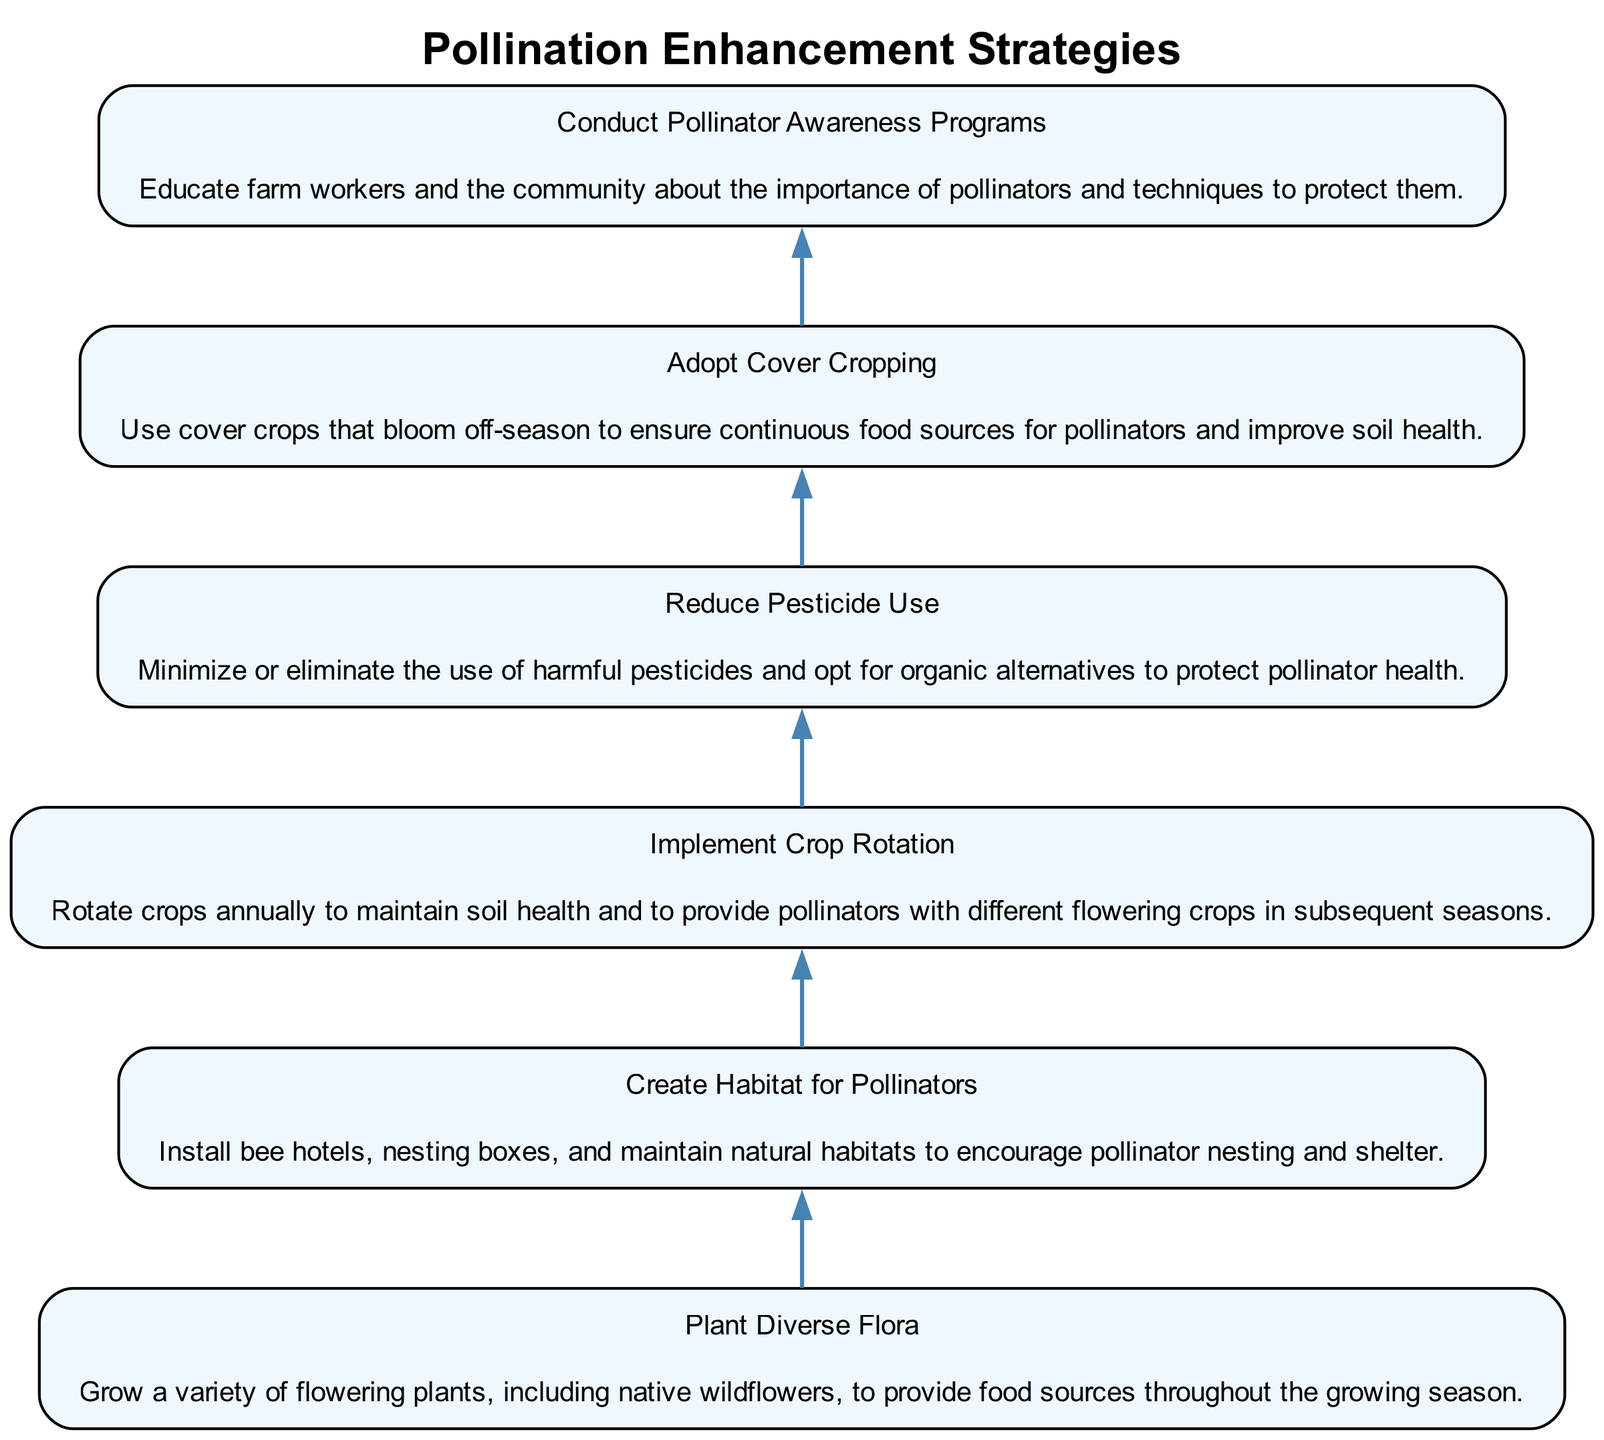What is the first strategy listed in the diagram? The diagram presents strategies in a bottom-up flow, with the first strategy being at the top. According to the data, the first strategy listed is "Plant Diverse Flora."
Answer: Plant Diverse Flora How many strategies are outlined in the diagram? The diagram contains six nodes, each representing a strategy for pollination enhancement as outlined in the data provided.
Answer: 6 What is the purpose of "Create Habitat for Pollinators"? Each node in the diagram describes specific strategies, and "Create Habitat for Pollinators" focuses on installing bee hotels and maintaining habitats for nesting. This information is directly related to the description provided for that node.
Answer: Install bee hotels and nesting boxes Which strategy directly emphasizes reducing chemicals near pollinators? Among the strategies, "Reduce Pesticide Use" is specifically focused on minimizing harmful pesticides to protect pollinators. This information is contained within the explanation of the strategy in the diagram.
Answer: Reduce Pesticide Use Which two strategies focus on the education and awareness of pollinators? The two strategies that emphasize education and awareness are "Conduct Pollinator Awareness Programs" and "Create Habitat for Pollinators." "Conduct Pollinator Awareness Programs" explicitly mentions educating the community about pollinator importance, while "Create Habitat for Pollinators" implies a broader educational context regarding habitat.
Answer: Conduct Pollinator Awareness Programs, Create Habitat for Pollinators What does the flow direction from "Plant Diverse Flora" to "Implement Crop Rotation" suggest? The flow from "Plant Diverse Flora" to "Implement Crop Rotation" indicates a sequential relationship where the diversity in flora allows for rotating crops, which is beneficial for soil and pollinators alike. This suggests a causal or supporting relationship between the two strategies.
Answer: Sequential relationship indicating support Which strategy follows the "Adopt Cover Cropping"? In the order of the diagram, "Conduct Pollinator Awareness Programs" directly follows "Adopt Cover Cropping," showing the progression of strategies in enhancing pollination through various methods.
Answer: Conduct Pollinator Awareness Programs What common goal unites all strategies outlined in the diagram? All strategies aim to enhance pollination rates and support pollinator populations, as outlined in their descriptions, focusing on sustainable farming practices. This common goal can be deduced from their collective focus on promoting a healthier environment for pollinators.
Answer: Enhance pollination rates and support pollinator populations Which strategy involves using crops that bloom in off-seasons? The strategy "Adopt Cover Cropping" is the one that specifies using cover crops that bloom off-season, ensuring continuous food sources for pollinators according to the provided description.
Answer: Adopt Cover Cropping 